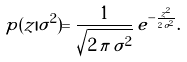Convert formula to latex. <formula><loc_0><loc_0><loc_500><loc_500>p ( z | \sigma ^ { 2 } ) = \frac { 1 } { \sqrt { 2 \, \pi \, \sigma ^ { 2 } } } \, e ^ { - \frac { z ^ { 2 } } { 2 \, \sigma ^ { 2 } } } .</formula> 